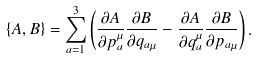<formula> <loc_0><loc_0><loc_500><loc_500>\{ A , B \} = \sum _ { a = 1 } ^ { 3 } \left ( \frac { \partial A } { \partial { p _ { a } ^ { \mu } } } \frac { \partial B } { \partial { q _ { a \mu } } } - \frac { \partial A } { \partial { q _ { a } ^ { \mu } } } \frac { \partial B } { \partial { p _ { a \mu } } } \right ) .</formula> 